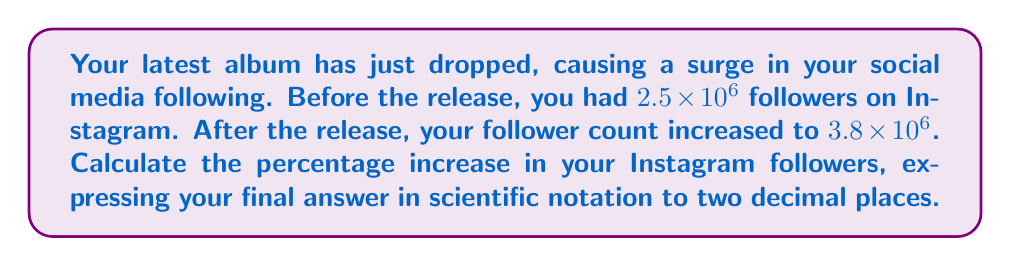Give your solution to this math problem. To calculate the percentage increase, we'll follow these steps:

1) First, calculate the absolute increase in followers:
   $3.8 \times 10^6 - 2.5 \times 10^6 = 1.3 \times 10^6$

2) To find the percentage increase, divide the increase by the original number and multiply by 100:

   $$\text{Percentage Increase} = \frac{\text{Increase}}{\text{Original}} \times 100$$

   $$= \frac{1.3 \times 10^6}{2.5 \times 10^6} \times 100$$

3) Simplify the fraction:
   $$= \frac{1.3}{2.5} \times 100$$

4) Perform the division:
   $$= 0.52 \times 100 = 52$$

5) Convert to scientific notation:
   $$52 = 5.2 \times 10^1$$

Therefore, the percentage increase in Instagram followers is $5.2 \times 10^1\%$.
Answer: $5.2 \times 10^1\%$ 